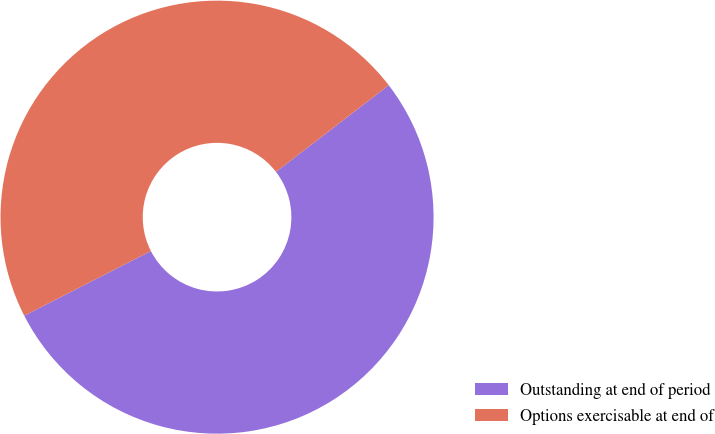Convert chart to OTSL. <chart><loc_0><loc_0><loc_500><loc_500><pie_chart><fcel>Outstanding at end of period<fcel>Options exercisable at end of<nl><fcel>52.91%<fcel>47.09%<nl></chart> 